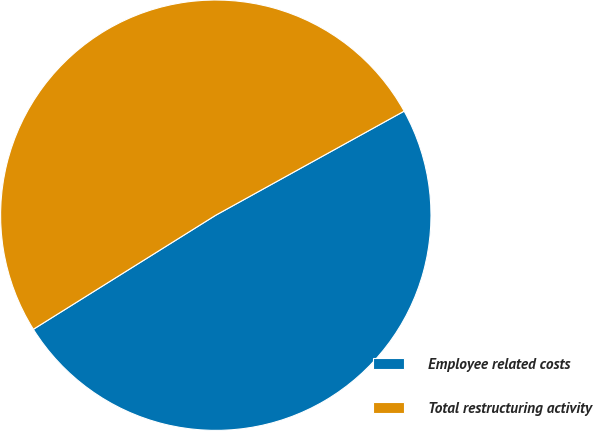Convert chart to OTSL. <chart><loc_0><loc_0><loc_500><loc_500><pie_chart><fcel>Employee related costs<fcel>Total restructuring activity<nl><fcel>49.14%<fcel>50.86%<nl></chart> 